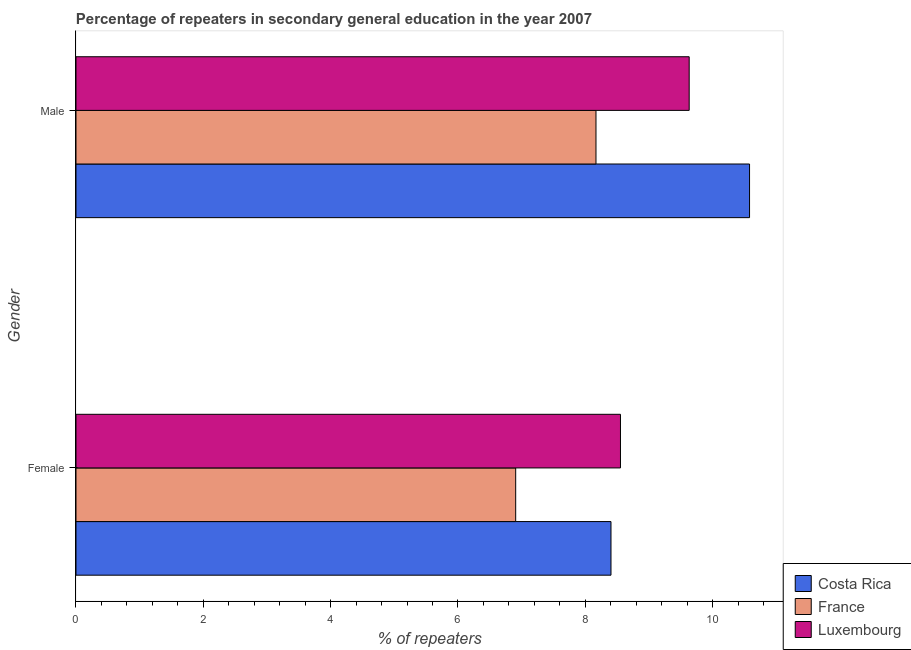How many bars are there on the 1st tick from the top?
Your response must be concise. 3. What is the label of the 1st group of bars from the top?
Your answer should be compact. Male. What is the percentage of female repeaters in Luxembourg?
Offer a very short reply. 8.55. Across all countries, what is the maximum percentage of male repeaters?
Keep it short and to the point. 10.58. Across all countries, what is the minimum percentage of female repeaters?
Provide a succinct answer. 6.91. In which country was the percentage of male repeaters maximum?
Keep it short and to the point. Costa Rica. What is the total percentage of female repeaters in the graph?
Your answer should be very brief. 23.86. What is the difference between the percentage of female repeaters in France and that in Costa Rica?
Your response must be concise. -1.5. What is the difference between the percentage of male repeaters in France and the percentage of female repeaters in Luxembourg?
Provide a short and direct response. -0.38. What is the average percentage of female repeaters per country?
Make the answer very short. 7.95. What is the difference between the percentage of female repeaters and percentage of male repeaters in Luxembourg?
Ensure brevity in your answer.  -1.08. What is the ratio of the percentage of male repeaters in Costa Rica to that in France?
Give a very brief answer. 1.3. Is the percentage of male repeaters in France less than that in Costa Rica?
Your response must be concise. Yes. What does the 3rd bar from the bottom in Male represents?
Make the answer very short. Luxembourg. How many bars are there?
Offer a very short reply. 6. Are all the bars in the graph horizontal?
Your answer should be very brief. Yes. How many countries are there in the graph?
Offer a very short reply. 3. What is the title of the graph?
Your response must be concise. Percentage of repeaters in secondary general education in the year 2007. What is the label or title of the X-axis?
Keep it short and to the point. % of repeaters. What is the % of repeaters of Costa Rica in Female?
Offer a terse response. 8.4. What is the % of repeaters of France in Female?
Your answer should be compact. 6.91. What is the % of repeaters of Luxembourg in Female?
Your response must be concise. 8.55. What is the % of repeaters in Costa Rica in Male?
Give a very brief answer. 10.58. What is the % of repeaters in France in Male?
Your answer should be very brief. 8.17. What is the % of repeaters of Luxembourg in Male?
Offer a terse response. 9.63. Across all Gender, what is the maximum % of repeaters of Costa Rica?
Provide a short and direct response. 10.58. Across all Gender, what is the maximum % of repeaters of France?
Your answer should be compact. 8.17. Across all Gender, what is the maximum % of repeaters in Luxembourg?
Provide a succinct answer. 9.63. Across all Gender, what is the minimum % of repeaters of Costa Rica?
Make the answer very short. 8.4. Across all Gender, what is the minimum % of repeaters of France?
Offer a very short reply. 6.91. Across all Gender, what is the minimum % of repeaters of Luxembourg?
Ensure brevity in your answer.  8.55. What is the total % of repeaters of Costa Rica in the graph?
Offer a very short reply. 18.98. What is the total % of repeaters of France in the graph?
Keep it short and to the point. 15.07. What is the total % of repeaters of Luxembourg in the graph?
Offer a very short reply. 18.18. What is the difference between the % of repeaters of Costa Rica in Female and that in Male?
Your response must be concise. -2.18. What is the difference between the % of repeaters of France in Female and that in Male?
Offer a very short reply. -1.26. What is the difference between the % of repeaters in Luxembourg in Female and that in Male?
Offer a very short reply. -1.08. What is the difference between the % of repeaters of Costa Rica in Female and the % of repeaters of France in Male?
Offer a terse response. 0.24. What is the difference between the % of repeaters of Costa Rica in Female and the % of repeaters of Luxembourg in Male?
Ensure brevity in your answer.  -1.23. What is the difference between the % of repeaters of France in Female and the % of repeaters of Luxembourg in Male?
Your answer should be compact. -2.73. What is the average % of repeaters in Costa Rica per Gender?
Keep it short and to the point. 9.49. What is the average % of repeaters in France per Gender?
Ensure brevity in your answer.  7.54. What is the average % of repeaters in Luxembourg per Gender?
Make the answer very short. 9.09. What is the difference between the % of repeaters in Costa Rica and % of repeaters in France in Female?
Offer a terse response. 1.5. What is the difference between the % of repeaters in Costa Rica and % of repeaters in Luxembourg in Female?
Give a very brief answer. -0.15. What is the difference between the % of repeaters in France and % of repeaters in Luxembourg in Female?
Your answer should be very brief. -1.65. What is the difference between the % of repeaters in Costa Rica and % of repeaters in France in Male?
Provide a succinct answer. 2.41. What is the difference between the % of repeaters in Costa Rica and % of repeaters in Luxembourg in Male?
Ensure brevity in your answer.  0.95. What is the difference between the % of repeaters of France and % of repeaters of Luxembourg in Male?
Ensure brevity in your answer.  -1.46. What is the ratio of the % of repeaters in Costa Rica in Female to that in Male?
Offer a very short reply. 0.79. What is the ratio of the % of repeaters in France in Female to that in Male?
Offer a very short reply. 0.85. What is the ratio of the % of repeaters of Luxembourg in Female to that in Male?
Offer a very short reply. 0.89. What is the difference between the highest and the second highest % of repeaters in Costa Rica?
Provide a succinct answer. 2.18. What is the difference between the highest and the second highest % of repeaters of France?
Make the answer very short. 1.26. What is the difference between the highest and the second highest % of repeaters of Luxembourg?
Give a very brief answer. 1.08. What is the difference between the highest and the lowest % of repeaters of Costa Rica?
Your answer should be compact. 2.18. What is the difference between the highest and the lowest % of repeaters of France?
Provide a succinct answer. 1.26. What is the difference between the highest and the lowest % of repeaters of Luxembourg?
Ensure brevity in your answer.  1.08. 